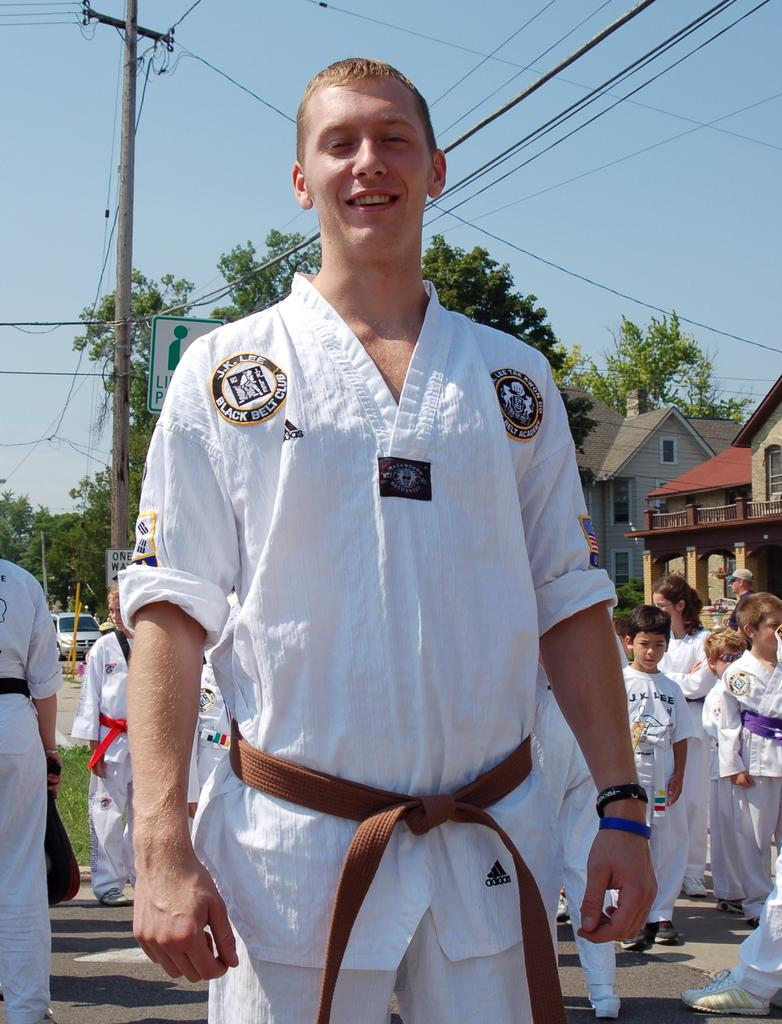<image>
Describe the image concisely. man wearing kung fu outfit with brown belt and has shoulder patch for j.k. lee black belt club 